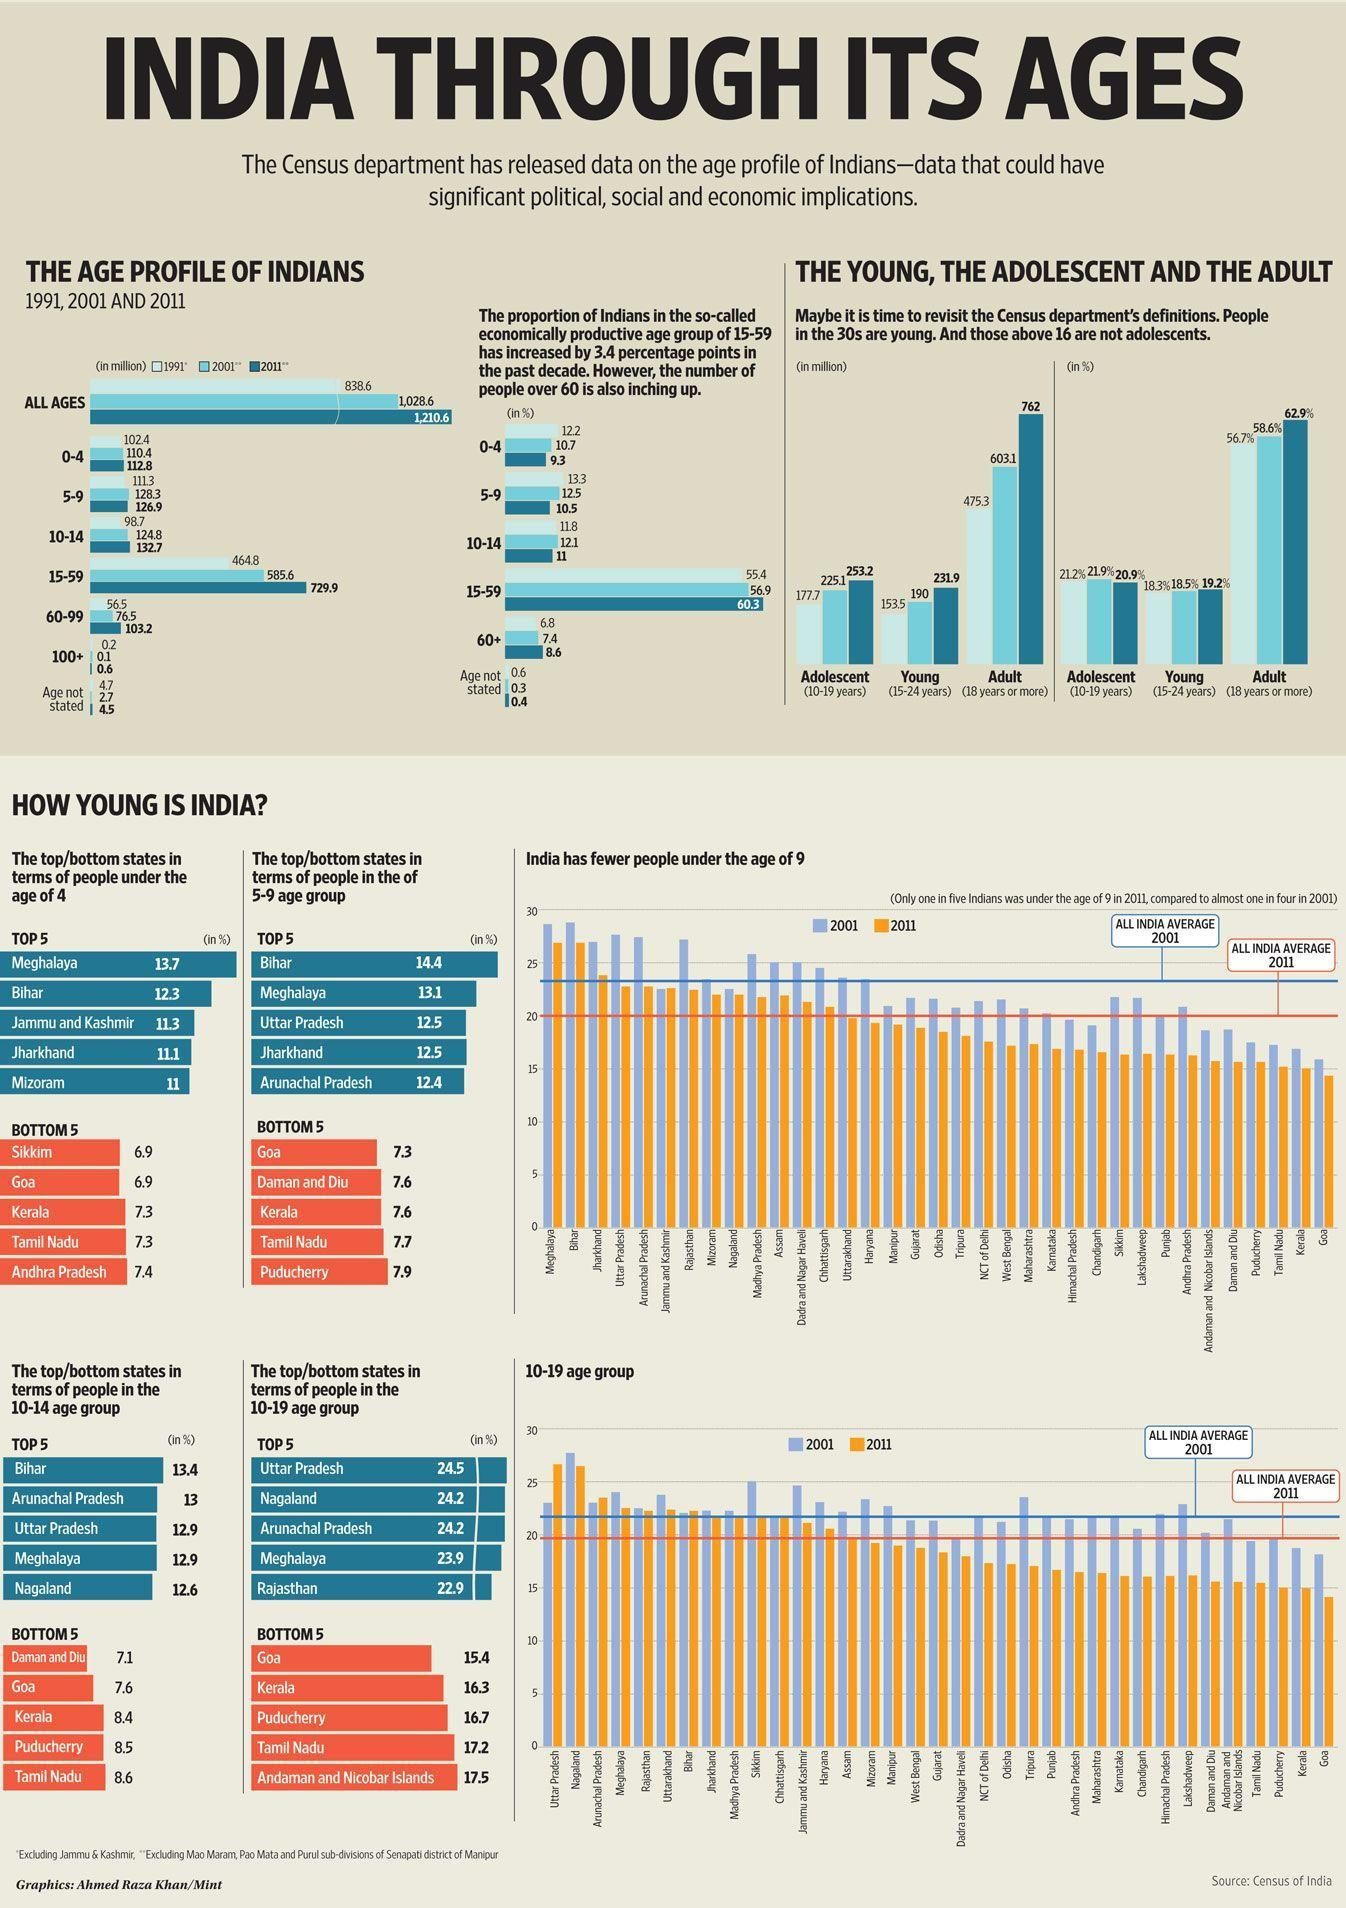What percentage of Indians are in the age group of 15-59 years in 2001?
Answer the question with a short phrase. 56.9 What percentage of Indians are in the age group of 60+ years in 1991? 6.8 Which state in India has the least percent of people in the age group of 5-9 years? Goa What was the total population (in millions) of India in 1991? 838.6 What percent of the people are in the age group of 10-14 years in Kerala? 8.4 How many people (in millions) were aged 100+ years in India in 2001? 0.1 Which state in India has the highest percent of people under the age of 4 years? Meghalaya How many people (in millions) were aged 10-14 years in India in 2011? 132.7 Which Indian state has has the highest percent of people in the age group of 10-19 years? Uttar Pradesh 